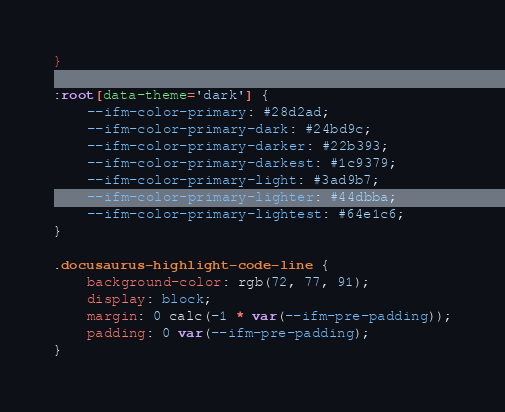<code> <loc_0><loc_0><loc_500><loc_500><_CSS_>}

:root[data-theme='dark'] {
    --ifm-color-primary: #28d2ad;
    --ifm-color-primary-dark: #24bd9c;
    --ifm-color-primary-darker: #22b393;
    --ifm-color-primary-darkest: #1c9379;
    --ifm-color-primary-light: #3ad9b7;
    --ifm-color-primary-lighter: #44dbba;
    --ifm-color-primary-lightest: #64e1c6;
}

.docusaurus-highlight-code-line {
    background-color: rgb(72, 77, 91);
    display: block;
    margin: 0 calc(-1 * var(--ifm-pre-padding));
    padding: 0 var(--ifm-pre-padding);
}
</code> 